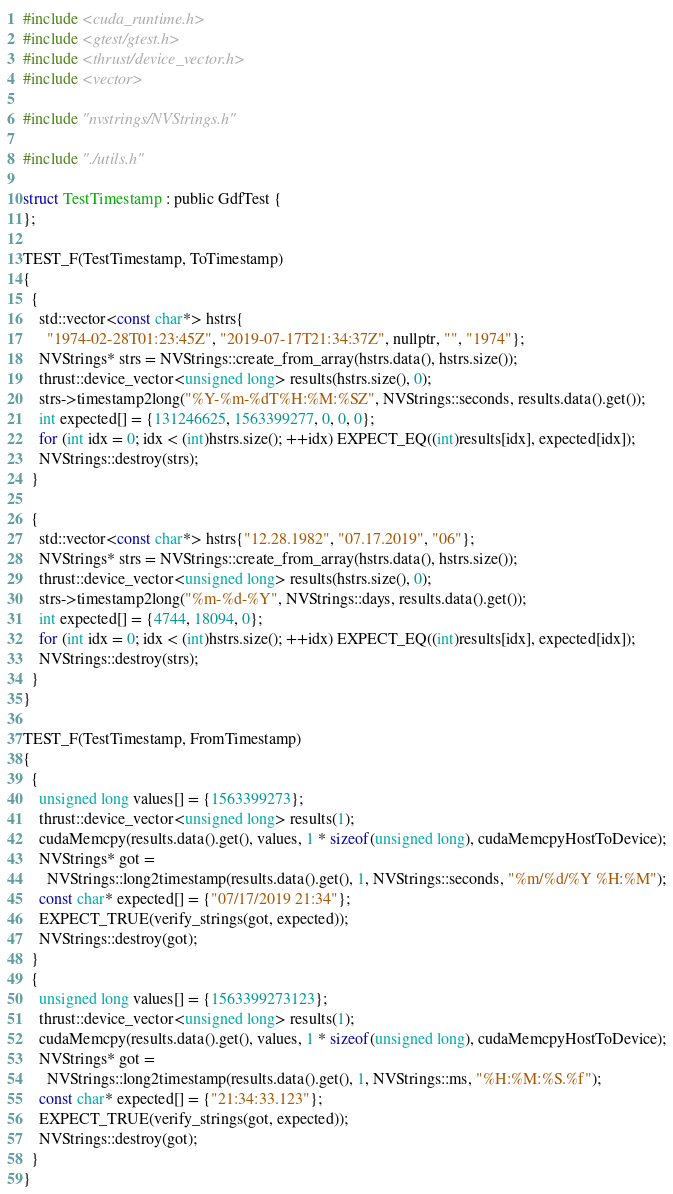<code> <loc_0><loc_0><loc_500><loc_500><_Cuda_>#include <cuda_runtime.h>
#include <gtest/gtest.h>
#include <thrust/device_vector.h>
#include <vector>

#include "nvstrings/NVStrings.h"

#include "./utils.h"

struct TestTimestamp : public GdfTest {
};

TEST_F(TestTimestamp, ToTimestamp)
{
  {
    std::vector<const char*> hstrs{
      "1974-02-28T01:23:45Z", "2019-07-17T21:34:37Z", nullptr, "", "1974"};
    NVStrings* strs = NVStrings::create_from_array(hstrs.data(), hstrs.size());
    thrust::device_vector<unsigned long> results(hstrs.size(), 0);
    strs->timestamp2long("%Y-%m-%dT%H:%M:%SZ", NVStrings::seconds, results.data().get());
    int expected[] = {131246625, 1563399277, 0, 0, 0};
    for (int idx = 0; idx < (int)hstrs.size(); ++idx) EXPECT_EQ((int)results[idx], expected[idx]);
    NVStrings::destroy(strs);
  }

  {
    std::vector<const char*> hstrs{"12.28.1982", "07.17.2019", "06"};
    NVStrings* strs = NVStrings::create_from_array(hstrs.data(), hstrs.size());
    thrust::device_vector<unsigned long> results(hstrs.size(), 0);
    strs->timestamp2long("%m-%d-%Y", NVStrings::days, results.data().get());
    int expected[] = {4744, 18094, 0};
    for (int idx = 0; idx < (int)hstrs.size(); ++idx) EXPECT_EQ((int)results[idx], expected[idx]);
    NVStrings::destroy(strs);
  }
}

TEST_F(TestTimestamp, FromTimestamp)
{
  {
    unsigned long values[] = {1563399273};
    thrust::device_vector<unsigned long> results(1);
    cudaMemcpy(results.data().get(), values, 1 * sizeof(unsigned long), cudaMemcpyHostToDevice);
    NVStrings* got =
      NVStrings::long2timestamp(results.data().get(), 1, NVStrings::seconds, "%m/%d/%Y %H:%M");
    const char* expected[] = {"07/17/2019 21:34"};
    EXPECT_TRUE(verify_strings(got, expected));
    NVStrings::destroy(got);
  }
  {
    unsigned long values[] = {1563399273123};
    thrust::device_vector<unsigned long> results(1);
    cudaMemcpy(results.data().get(), values, 1 * sizeof(unsigned long), cudaMemcpyHostToDevice);
    NVStrings* got =
      NVStrings::long2timestamp(results.data().get(), 1, NVStrings::ms, "%H:%M:%S.%f");
    const char* expected[] = {"21:34:33.123"};
    EXPECT_TRUE(verify_strings(got, expected));
    NVStrings::destroy(got);
  }
}
</code> 